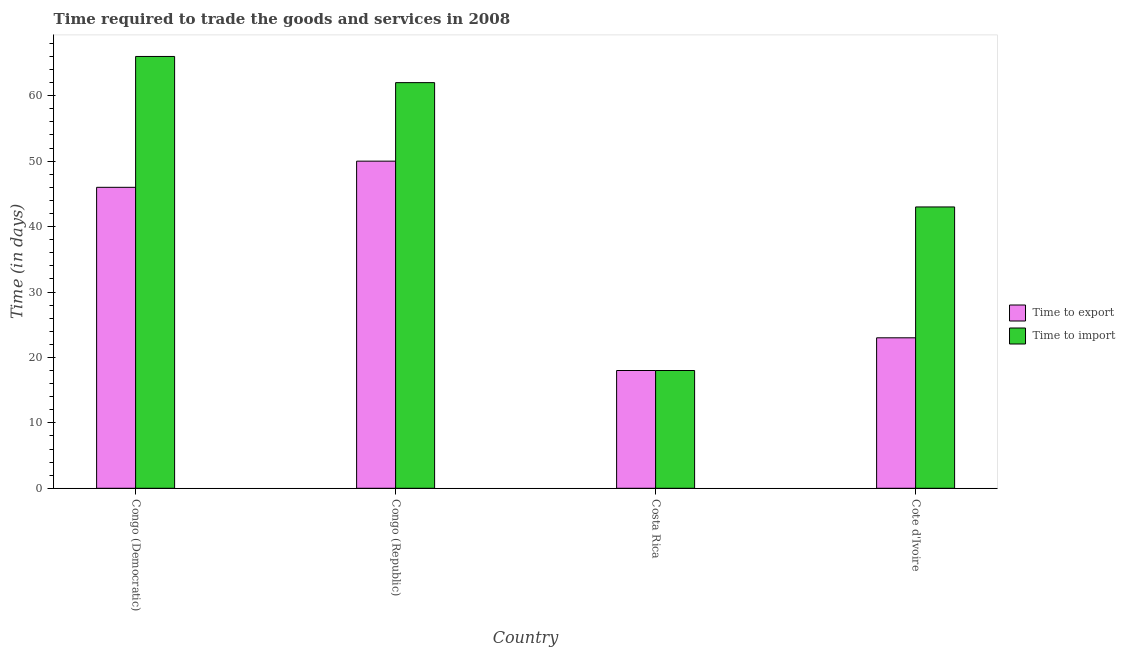How many groups of bars are there?
Your answer should be compact. 4. Are the number of bars on each tick of the X-axis equal?
Your answer should be compact. Yes. How many bars are there on the 3rd tick from the right?
Provide a succinct answer. 2. What is the label of the 4th group of bars from the left?
Ensure brevity in your answer.  Cote d'Ivoire. In how many cases, is the number of bars for a given country not equal to the number of legend labels?
Offer a very short reply. 0. Across all countries, what is the maximum time to import?
Give a very brief answer. 66. Across all countries, what is the minimum time to import?
Your answer should be compact. 18. In which country was the time to export maximum?
Offer a terse response. Congo (Republic). In which country was the time to import minimum?
Give a very brief answer. Costa Rica. What is the total time to export in the graph?
Your answer should be very brief. 137. What is the difference between the time to import in Congo (Democratic) and that in Cote d'Ivoire?
Make the answer very short. 23. What is the average time to export per country?
Make the answer very short. 34.25. What is the ratio of the time to import in Congo (Republic) to that in Cote d'Ivoire?
Provide a short and direct response. 1.44. What is the difference between the highest and the second highest time to import?
Your response must be concise. 4. What is the difference between the highest and the lowest time to export?
Provide a short and direct response. 32. What does the 1st bar from the left in Costa Rica represents?
Your answer should be compact. Time to export. What does the 1st bar from the right in Cote d'Ivoire represents?
Your response must be concise. Time to import. How many bars are there?
Offer a very short reply. 8. Are all the bars in the graph horizontal?
Provide a succinct answer. No. What is the difference between two consecutive major ticks on the Y-axis?
Provide a succinct answer. 10. Are the values on the major ticks of Y-axis written in scientific E-notation?
Your answer should be very brief. No. Does the graph contain grids?
Make the answer very short. No. Where does the legend appear in the graph?
Offer a terse response. Center right. How are the legend labels stacked?
Provide a succinct answer. Vertical. What is the title of the graph?
Provide a succinct answer. Time required to trade the goods and services in 2008. What is the label or title of the X-axis?
Your answer should be very brief. Country. What is the label or title of the Y-axis?
Provide a succinct answer. Time (in days). What is the Time (in days) in Time to export in Congo (Democratic)?
Give a very brief answer. 46. What is the Time (in days) in Time to import in Congo (Democratic)?
Your answer should be compact. 66. What is the Time (in days) in Time to export in Congo (Republic)?
Give a very brief answer. 50. What is the Time (in days) in Time to import in Costa Rica?
Your response must be concise. 18. Across all countries, what is the minimum Time (in days) in Time to import?
Your response must be concise. 18. What is the total Time (in days) in Time to export in the graph?
Your answer should be very brief. 137. What is the total Time (in days) of Time to import in the graph?
Provide a short and direct response. 189. What is the difference between the Time (in days) of Time to import in Congo (Democratic) and that in Congo (Republic)?
Keep it short and to the point. 4. What is the difference between the Time (in days) in Time to export in Congo (Democratic) and that in Costa Rica?
Make the answer very short. 28. What is the difference between the Time (in days) in Time to export in Congo (Republic) and that in Cote d'Ivoire?
Make the answer very short. 27. What is the difference between the Time (in days) in Time to import in Congo (Republic) and that in Cote d'Ivoire?
Your answer should be very brief. 19. What is the difference between the Time (in days) of Time to export in Costa Rica and that in Cote d'Ivoire?
Your response must be concise. -5. What is the difference between the Time (in days) of Time to export in Congo (Democratic) and the Time (in days) of Time to import in Costa Rica?
Ensure brevity in your answer.  28. What is the difference between the Time (in days) in Time to export in Congo (Democratic) and the Time (in days) in Time to import in Cote d'Ivoire?
Provide a short and direct response. 3. What is the difference between the Time (in days) in Time to export in Congo (Republic) and the Time (in days) in Time to import in Costa Rica?
Make the answer very short. 32. What is the average Time (in days) of Time to export per country?
Your answer should be very brief. 34.25. What is the average Time (in days) of Time to import per country?
Your answer should be very brief. 47.25. What is the difference between the Time (in days) of Time to export and Time (in days) of Time to import in Congo (Democratic)?
Provide a short and direct response. -20. What is the difference between the Time (in days) of Time to export and Time (in days) of Time to import in Costa Rica?
Give a very brief answer. 0. What is the ratio of the Time (in days) of Time to import in Congo (Democratic) to that in Congo (Republic)?
Offer a very short reply. 1.06. What is the ratio of the Time (in days) in Time to export in Congo (Democratic) to that in Costa Rica?
Your answer should be compact. 2.56. What is the ratio of the Time (in days) of Time to import in Congo (Democratic) to that in Costa Rica?
Your response must be concise. 3.67. What is the ratio of the Time (in days) of Time to import in Congo (Democratic) to that in Cote d'Ivoire?
Give a very brief answer. 1.53. What is the ratio of the Time (in days) of Time to export in Congo (Republic) to that in Costa Rica?
Give a very brief answer. 2.78. What is the ratio of the Time (in days) in Time to import in Congo (Republic) to that in Costa Rica?
Make the answer very short. 3.44. What is the ratio of the Time (in days) of Time to export in Congo (Republic) to that in Cote d'Ivoire?
Your answer should be compact. 2.17. What is the ratio of the Time (in days) in Time to import in Congo (Republic) to that in Cote d'Ivoire?
Your response must be concise. 1.44. What is the ratio of the Time (in days) of Time to export in Costa Rica to that in Cote d'Ivoire?
Your answer should be very brief. 0.78. What is the ratio of the Time (in days) of Time to import in Costa Rica to that in Cote d'Ivoire?
Ensure brevity in your answer.  0.42. What is the difference between the highest and the second highest Time (in days) in Time to export?
Offer a very short reply. 4. What is the difference between the highest and the second highest Time (in days) in Time to import?
Offer a terse response. 4. What is the difference between the highest and the lowest Time (in days) of Time to export?
Offer a terse response. 32. 